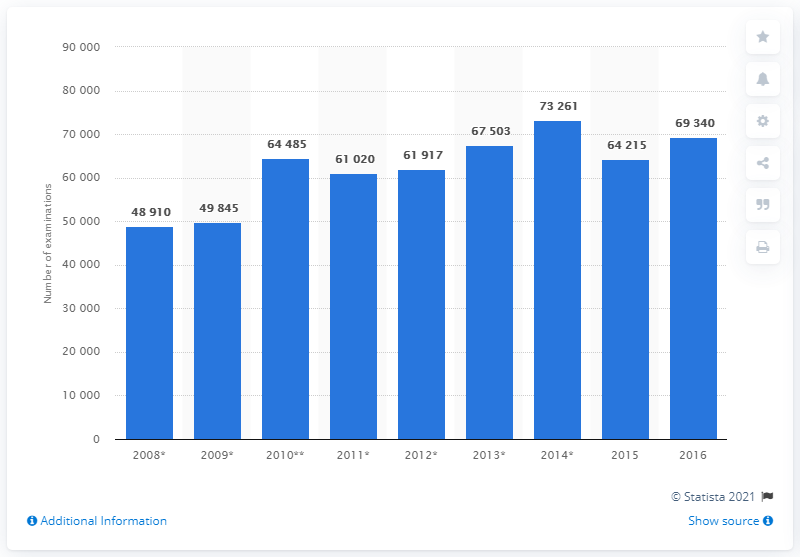Specify some key components in this picture. In 2016, a total of 69,340 MRI scan examinations were conducted in Estonia. 